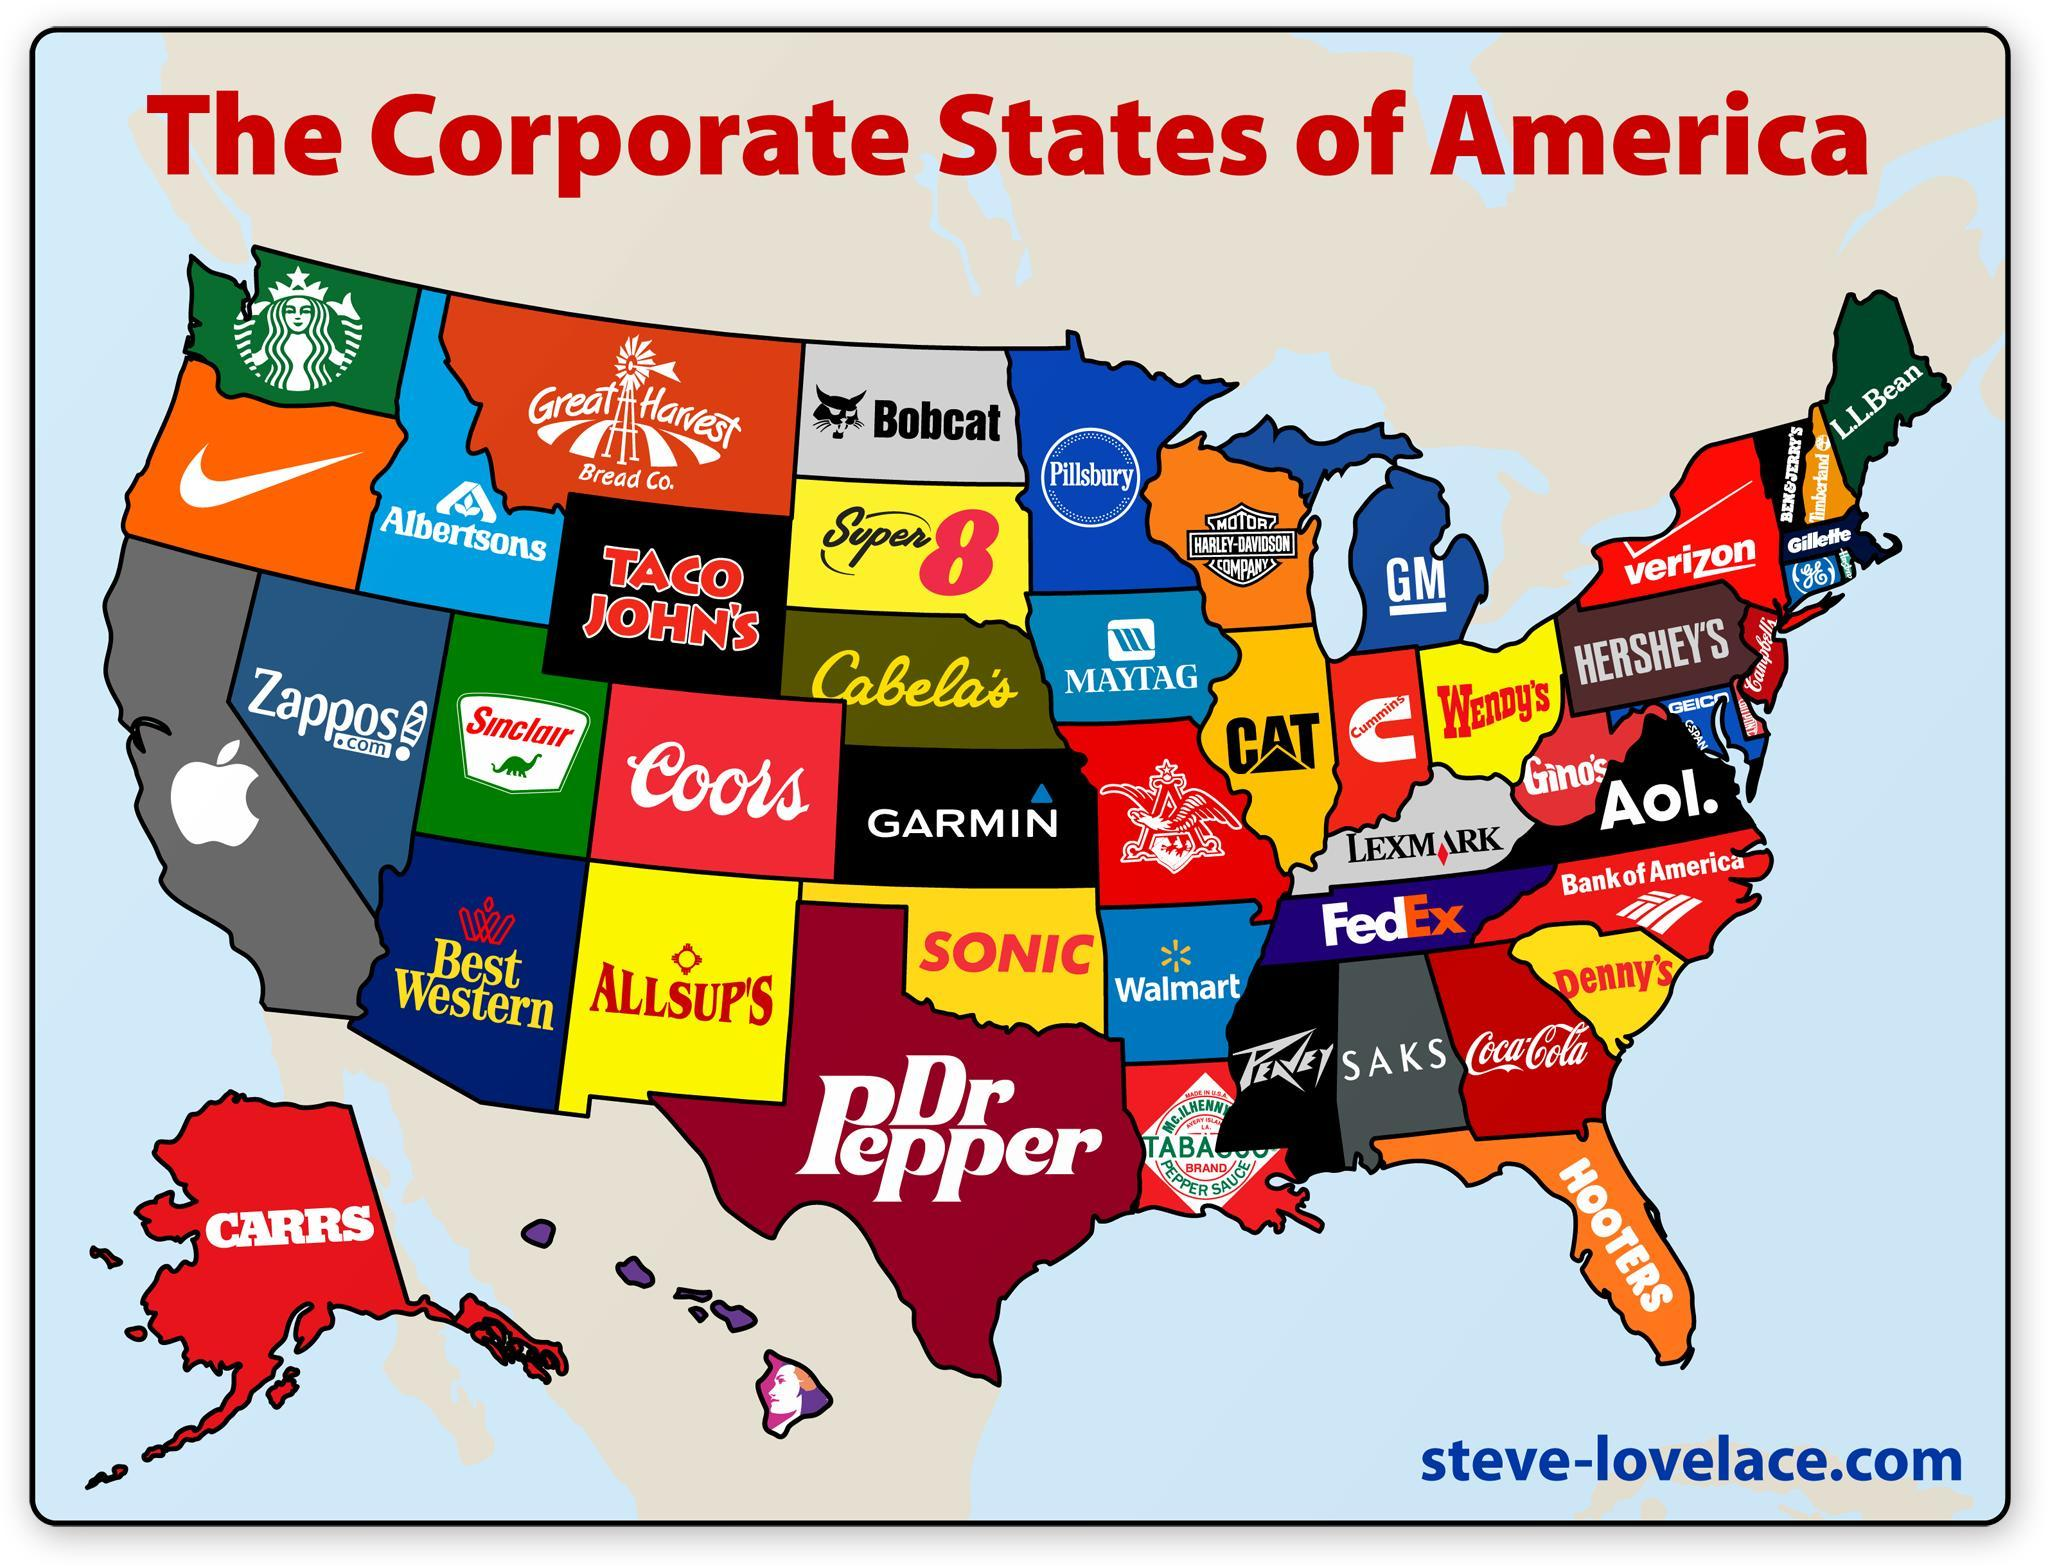How many logos have a black background?
Answer the question with a short phrase. 5 How many logos have a green background color? 3 